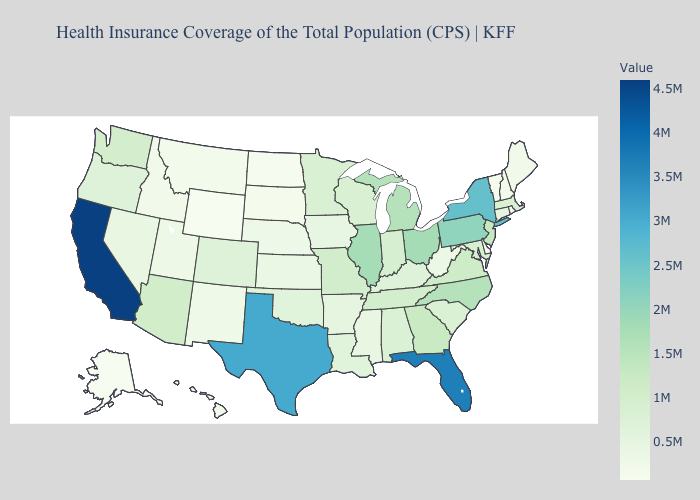Does Rhode Island have the lowest value in the Northeast?
Answer briefly. No. Does California have the highest value in the USA?
Be succinct. Yes. Which states have the highest value in the USA?
Concise answer only. California. Which states have the highest value in the USA?
Concise answer only. California. Does South Carolina have the highest value in the South?
Be succinct. No. Does Alaska have the lowest value in the USA?
Concise answer only. Yes. Which states have the lowest value in the West?
Concise answer only. Alaska. 